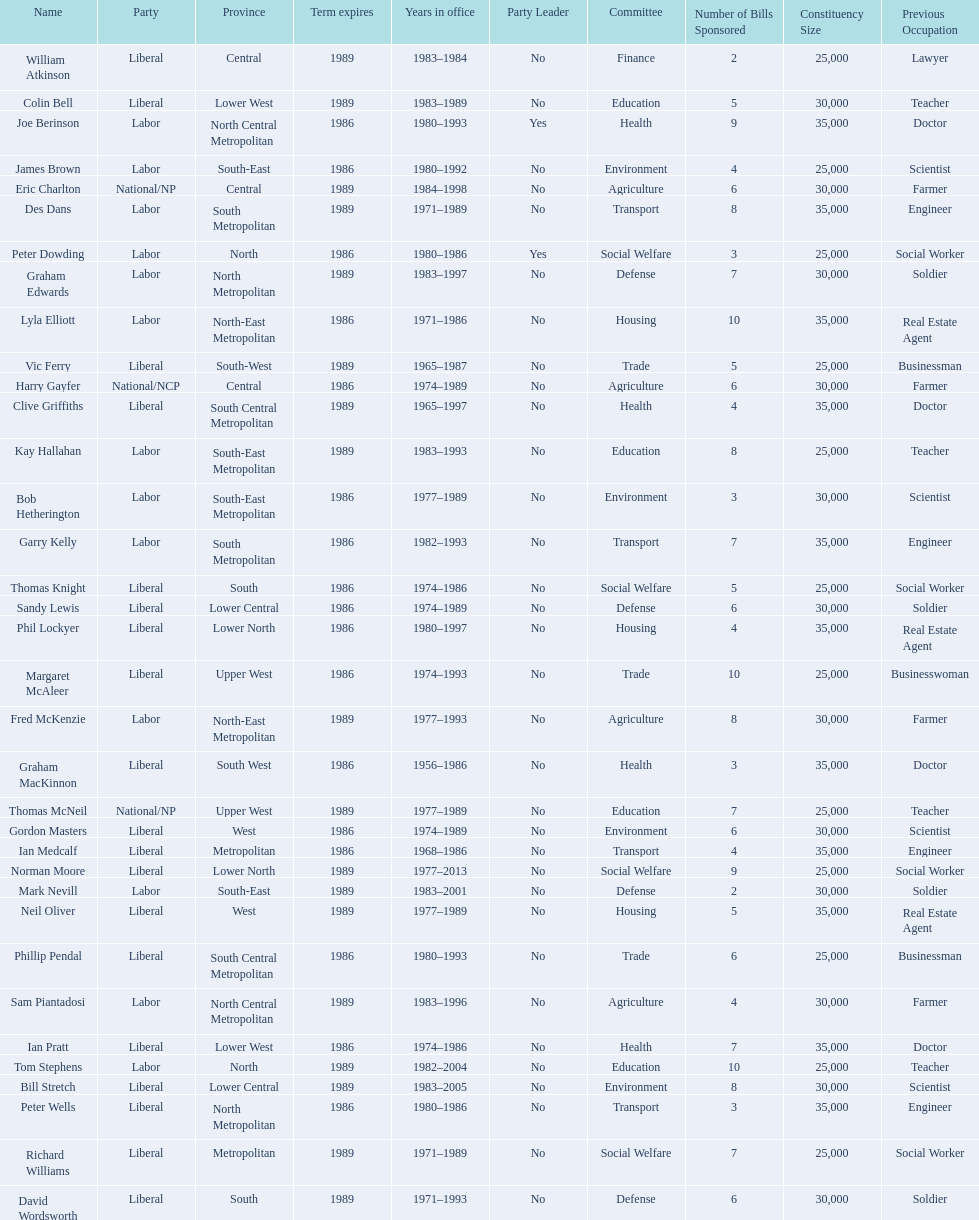Write the full table. {'header': ['Name', 'Party', 'Province', 'Term expires', 'Years in office', 'Party Leader', 'Committee', 'Number of Bills Sponsored', 'Constituency Size', 'Previous Occupation'], 'rows': [['William Atkinson', 'Liberal', 'Central', '1989', '1983–1984', 'No', 'Finance', '2', '25,000', 'Lawyer'], ['Colin Bell', 'Liberal', 'Lower West', '1989', '1983–1989', 'No', 'Education', '5', '30,000', 'Teacher'], ['Joe Berinson', 'Labor', 'North Central Metropolitan', '1986', '1980–1993', 'Yes', 'Health', '9', '35,000', 'Doctor'], ['James Brown', 'Labor', 'South-East', '1986', '1980–1992', 'No', 'Environment', '4', '25,000', 'Scientist'], ['Eric Charlton', 'National/NP', 'Central', '1989', '1984–1998', 'No', 'Agriculture', '6', '30,000', 'Farmer'], ['Des Dans', 'Labor', 'South Metropolitan', '1989', '1971–1989', 'No', 'Transport', '8', '35,000', 'Engineer'], ['Peter Dowding', 'Labor', 'North', '1986', '1980–1986', 'Yes', 'Social Welfare', '3', '25,000', 'Social Worker'], ['Graham Edwards', 'Labor', 'North Metropolitan', '1989', '1983–1997', 'No', 'Defense', '7', '30,000', 'Soldier'], ['Lyla Elliott', 'Labor', 'North-East Metropolitan', '1986', '1971–1986', 'No', 'Housing', '10', '35,000', 'Real Estate Agent'], ['Vic Ferry', 'Liberal', 'South-West', '1989', '1965–1987', 'No', 'Trade', '5', '25,000', 'Businessman'], ['Harry Gayfer', 'National/NCP', 'Central', '1986', '1974–1989', 'No', 'Agriculture', '6', '30,000', 'Farmer'], ['Clive Griffiths', 'Liberal', 'South Central Metropolitan', '1989', '1965–1997', 'No', 'Health', '4', '35,000', 'Doctor'], ['Kay Hallahan', 'Labor', 'South-East Metropolitan', '1989', '1983–1993', 'No', 'Education', '8', '25,000', 'Teacher'], ['Bob Hetherington', 'Labor', 'South-East Metropolitan', '1986', '1977–1989', 'No', 'Environment', '3', '30,000', 'Scientist'], ['Garry Kelly', 'Labor', 'South Metropolitan', '1986', '1982–1993', 'No', 'Transport', '7', '35,000', 'Engineer'], ['Thomas Knight', 'Liberal', 'South', '1986', '1974–1986', 'No', 'Social Welfare', '5', '25,000', 'Social Worker'], ['Sandy Lewis', 'Liberal', 'Lower Central', '1986', '1974–1989', 'No', 'Defense', '6', '30,000', 'Soldier'], ['Phil Lockyer', 'Liberal', 'Lower North', '1986', '1980–1997', 'No', 'Housing', '4', '35,000', 'Real Estate Agent'], ['Margaret McAleer', 'Liberal', 'Upper West', '1986', '1974–1993', 'No', 'Trade', '10', '25,000', 'Businesswoman'], ['Fred McKenzie', 'Labor', 'North-East Metropolitan', '1989', '1977–1993', 'No', 'Agriculture', '8', '30,000', 'Farmer'], ['Graham MacKinnon', 'Liberal', 'South West', '1986', '1956–1986', 'No', 'Health', '3', '35,000', 'Doctor'], ['Thomas McNeil', 'National/NP', 'Upper West', '1989', '1977–1989', 'No', 'Education', '7', '25,000', 'Teacher'], ['Gordon Masters', 'Liberal', 'West', '1986', '1974–1989', 'No', 'Environment', '6', '30,000', 'Scientist'], ['Ian Medcalf', 'Liberal', 'Metropolitan', '1986', '1968–1986', 'No', 'Transport', '4', '35,000', 'Engineer'], ['Norman Moore', 'Liberal', 'Lower North', '1989', '1977–2013', 'No', 'Social Welfare', '9', '25,000', 'Social Worker'], ['Mark Nevill', 'Labor', 'South-East', '1989', '1983–2001', 'No', 'Defense', '2', '30,000', 'Soldier'], ['Neil Oliver', 'Liberal', 'West', '1989', '1977–1989', 'No', 'Housing', '5', '35,000', 'Real Estate Agent'], ['Phillip Pendal', 'Liberal', 'South Central Metropolitan', '1986', '1980–1993', 'No', 'Trade', '6', '25,000', 'Businessman'], ['Sam Piantadosi', 'Labor', 'North Central Metropolitan', '1989', '1983–1996', 'No', 'Agriculture', '4', '30,000', 'Farmer'], ['Ian Pratt', 'Liberal', 'Lower West', '1986', '1974–1986', 'No', 'Health', '7', '35,000', 'Doctor'], ['Tom Stephens', 'Labor', 'North', '1989', '1982–2004', 'No', 'Education', '10', '25,000', 'Teacher'], ['Bill Stretch', 'Liberal', 'Lower Central', '1989', '1983–2005', 'No', 'Environment', '8', '30,000', 'Scientist'], ['Peter Wells', 'Liberal', 'North Metropolitan', '1986', '1980–1986', 'No', 'Transport', '3', '35,000', 'Engineer'], ['Richard Williams', 'Liberal', 'Metropolitan', '1989', '1971–1989', 'No', 'Social Welfare', '7', '25,000', 'Social Worker'], ['David Wordsworth', 'Liberal', 'South', '1989', '1971–1993', 'No', 'Defense', '6', '30,000', 'Soldier']]} In which political party was phil lockyer involved? Liberal. 